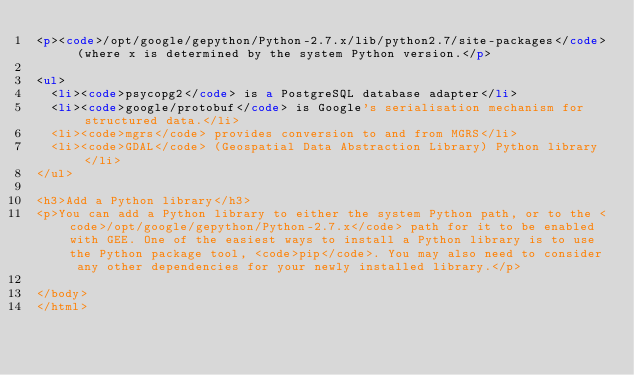Convert code to text. <code><loc_0><loc_0><loc_500><loc_500><_HTML_><p><code>/opt/google/gepython/Python-2.7.x/lib/python2.7/site-packages</code> (where x is determined by the system Python version.</p>

<ul>
  <li><code>psycopg2</code> is a PostgreSQL database adapter</li>
  <li><code>google/protobuf</code> is Google's serialisation mechanism for structured data.</li>
  <li><code>mgrs</code> provides conversion to and from MGRS</li>
  <li><code>GDAL</code> (Geospatial Data Abstraction Library) Python library</li>
</ul>

<h3>Add a Python library</h3>
<p>You can add a Python library to either the system Python path, or to the <code>/opt/google/gepython/Python-2.7.x</code> path for it to be enabled with GEE. One of the easiest ways to install a Python library is to use the Python package tool, <code>pip</code>. You may also need to consider any other dependencies for your newly installed library.</p>

</body>
</html>
</code> 